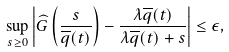<formula> <loc_0><loc_0><loc_500><loc_500>\sup _ { s \geq 0 } \left | \widehat { G } \left ( \frac { s } { \overline { q } ( t ) } \right ) - \frac { \lambda \overline { q } ( t ) } { \lambda \overline { q } ( t ) + s } \right | \leq \epsilon ,</formula> 